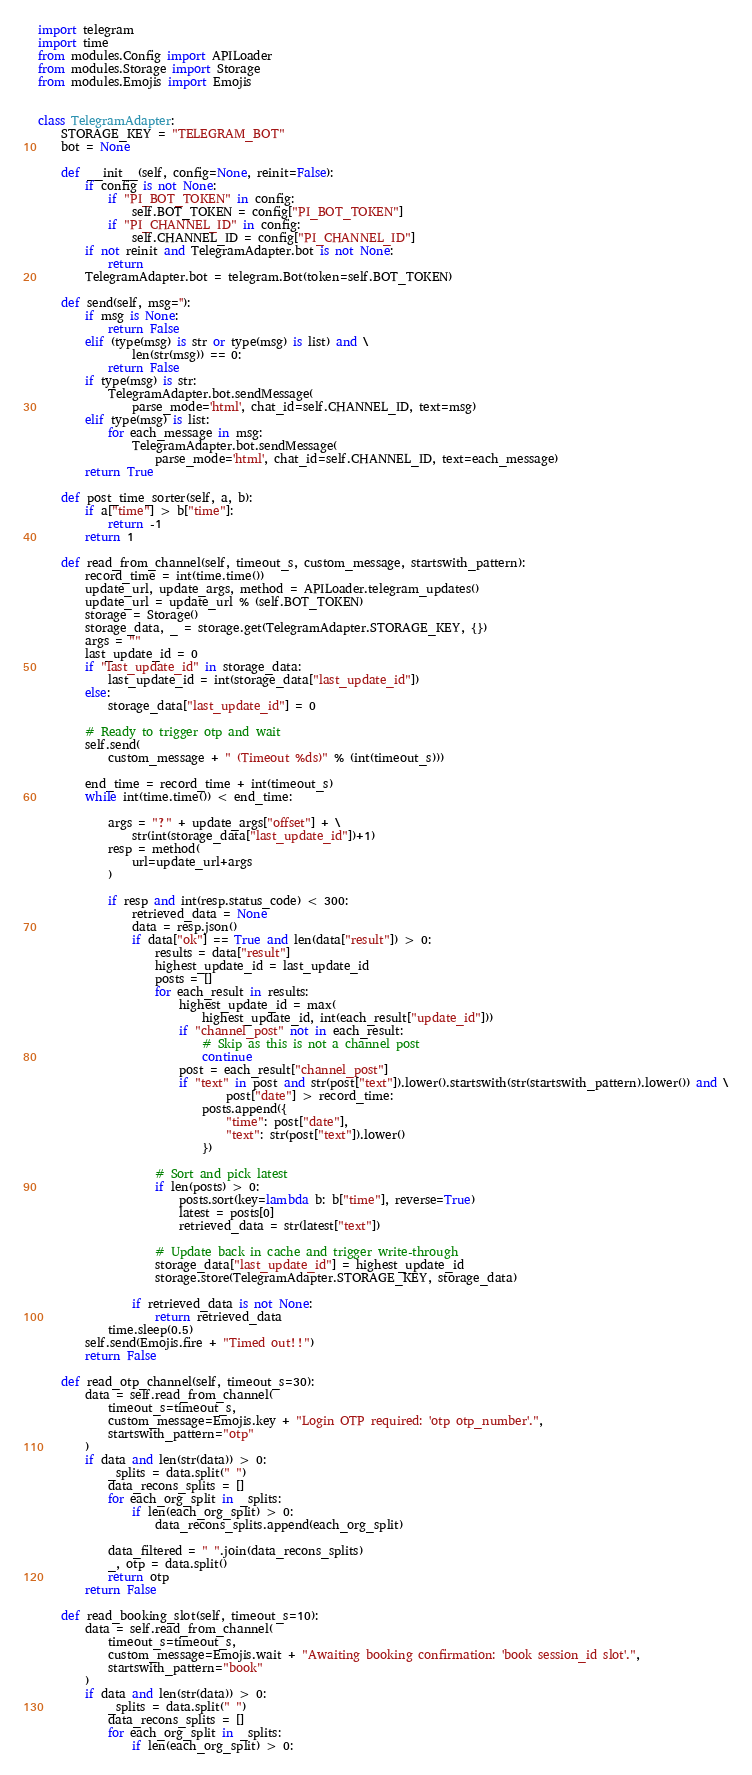<code> <loc_0><loc_0><loc_500><loc_500><_Python_>import telegram
import time
from modules.Config import APILoader
from modules.Storage import Storage
from modules.Emojis import Emojis


class TelegramAdapter:
	STORAGE_KEY = "TELEGRAM_BOT"
	bot = None

	def __init__(self, config=None, reinit=False):
		if config is not None:
			if "PI_BOT_TOKEN" in config:
				self.BOT_TOKEN = config["PI_BOT_TOKEN"]
			if "PI_CHANNEL_ID" in config:
				self.CHANNEL_ID = config["PI_CHANNEL_ID"]
		if not reinit and TelegramAdapter.bot is not None:
			return
		TelegramAdapter.bot = telegram.Bot(token=self.BOT_TOKEN)

	def send(self, msg=''):
		if msg is None:
			return False
		elif (type(msg) is str or type(msg) is list) and \
				len(str(msg)) == 0:
			return False
		if type(msg) is str:
			TelegramAdapter.bot.sendMessage(
				parse_mode='html', chat_id=self.CHANNEL_ID, text=msg)
		elif type(msg) is list:
			for each_message in msg:
				TelegramAdapter.bot.sendMessage(
					parse_mode='html', chat_id=self.CHANNEL_ID, text=each_message)
		return True

	def post_time_sorter(self, a, b):
		if a["time"] > b["time"]:
			return -1
		return 1

	def read_from_channel(self, timeout_s, custom_message, startswith_pattern):
		record_time = int(time.time())
		update_url, update_args, method = APILoader.telegram_updates()
		update_url = update_url % (self.BOT_TOKEN)
		storage = Storage()
		storage_data, _ = storage.get(TelegramAdapter.STORAGE_KEY, {})
		args = ""
		last_update_id = 0
		if "last_update_id" in storage_data:
			last_update_id = int(storage_data["last_update_id"])
		else:
			storage_data["last_update_id"] = 0

		# Ready to trigger otp and wait
		self.send(
			custom_message + " (Timeout %ds)" % (int(timeout_s)))

		end_time = record_time + int(timeout_s)
		while int(time.time()) < end_time:

			args = "?" + update_args["offset"] + \
				str(int(storage_data["last_update_id"])+1)
			resp = method(
				url=update_url+args
			)

			if resp and int(resp.status_code) < 300:
				retrieved_data = None
				data = resp.json()
				if data["ok"] == True and len(data["result"]) > 0:
					results = data["result"]
					highest_update_id = last_update_id
					posts = []
					for each_result in results:
						highest_update_id = max(
							highest_update_id, int(each_result["update_id"]))
						if "channel_post" not in each_result:
							# Skip as this is not a channel post
							continue
						post = each_result["channel_post"]
						if "text" in post and str(post["text"]).lower().startswith(str(startswith_pattern).lower()) and \
								post["date"] > record_time:
							posts.append({
								"time": post["date"],
								"text": str(post["text"]).lower()
							})

					# Sort and pick latest
					if len(posts) > 0:
						posts.sort(key=lambda b: b["time"], reverse=True)
						latest = posts[0]
						retrieved_data = str(latest["text"])

					# Update back in cache and trigger write-through
					storage_data["last_update_id"] = highest_update_id
					storage.store(TelegramAdapter.STORAGE_KEY, storage_data)

				if retrieved_data is not None:
					return retrieved_data
			time.sleep(0.5)
		self.send(Emojis.fire + "Timed out!!")
		return False

	def read_otp_channel(self, timeout_s=30):
		data = self.read_from_channel(
			timeout_s=timeout_s,
			custom_message=Emojis.key + "Login OTP required: 'otp otp_number'.",
			startswith_pattern="otp"
		)
		if data and len(str(data)) > 0:
			_splits = data.split(" ")
			data_recons_splits = []
			for each_org_split in _splits:
				if len(each_org_split) > 0:
					data_recons_splits.append(each_org_split)

			data_filtered = " ".join(data_recons_splits)
			_, otp = data.split()
			return otp
		return False

	def read_booking_slot(self, timeout_s=10):
		data = self.read_from_channel(
			timeout_s=timeout_s,
			custom_message=Emojis.wait + "Awaiting booking confirmation: 'book session_id slot'.",
			startswith_pattern="book"
		)
		if data and len(str(data)) > 0:
			_splits = data.split(" ")
			data_recons_splits = []
			for each_org_split in _splits:
				if len(each_org_split) > 0:</code> 